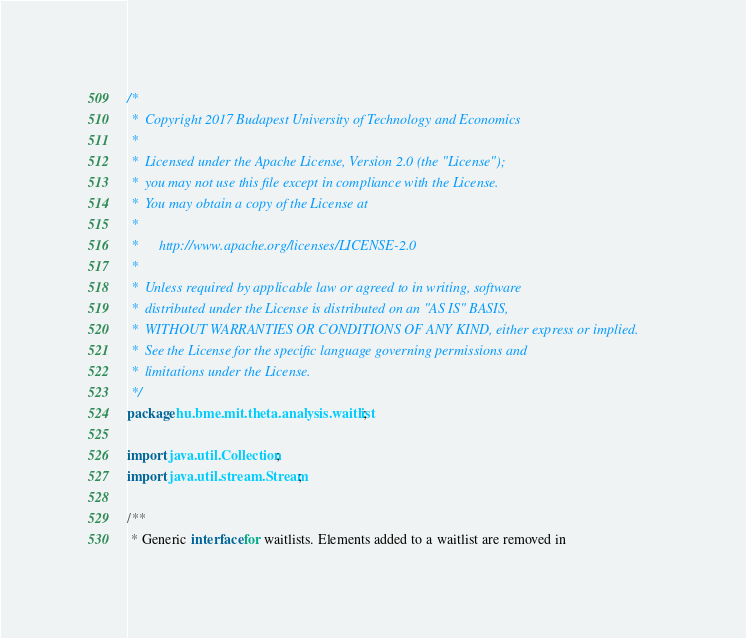Convert code to text. <code><loc_0><loc_0><loc_500><loc_500><_Java_>/*
 *  Copyright 2017 Budapest University of Technology and Economics
 *
 *  Licensed under the Apache License, Version 2.0 (the "License");
 *  you may not use this file except in compliance with the License.
 *  You may obtain a copy of the License at
 *
 *      http://www.apache.org/licenses/LICENSE-2.0
 *
 *  Unless required by applicable law or agreed to in writing, software
 *  distributed under the License is distributed on an "AS IS" BASIS,
 *  WITHOUT WARRANTIES OR CONDITIONS OF ANY KIND, either express or implied.
 *  See the License for the specific language governing permissions and
 *  limitations under the License.
 */
package hu.bme.mit.theta.analysis.waitlist;

import java.util.Collection;
import java.util.stream.Stream;

/**
 * Generic interface for waitlists. Elements added to a waitlist are removed in</code> 